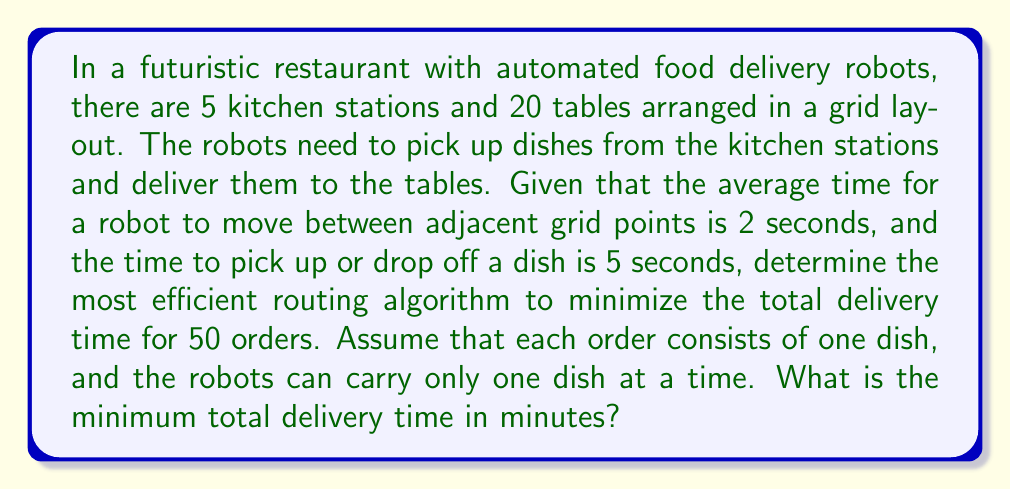Show me your answer to this math problem. To solve this problem, we need to apply the principles of the Traveling Salesman Problem (TSP) and optimize it for multiple robots. Let's break it down step-by-step:

1. Layout analysis:
   - 5 kitchen stations and 20 tables in a grid layout
   - Movement time between adjacent points: 2 seconds
   - Pick up/drop off time: 5 seconds

2. Optimal routing algorithm:
   The most efficient routing algorithm for this scenario would be a combination of the Nearest Neighbor algorithm and the concept of load balancing among robots.

3. Calculate the average distance:
   Assuming a uniform distribution of tables and kitchen stations, the average distance between a kitchen station and a table would be approximately half the grid diagonal.
   Let's assume a 5x5 grid for simplicity:
   Average distance = $\frac{1}{2}\sqrt{5^2 + 5^2} = \frac{5\sqrt{2}}{2}$ grid units

4. Calculate average travel time per order:
   Average travel time = $2 \times \frac{5\sqrt{2}}{2} = 5\sqrt{2}$ seconds

5. Calculate total time per order:
   Total time per order = Pick up time + Average travel time + Drop off time
   $T_{order} = 5 + 5\sqrt{2} + 5 = 10 + 5\sqrt{2}$ seconds

6. Calculate total time for all orders:
   Total time = $50 \times (10 + 5\sqrt{2})$ seconds

7. Convert to minutes:
   Total time in minutes = $\frac{50 \times (10 + 5\sqrt{2})}{60}$ minutes
   $= \frac{500 + 250\sqrt{2}}{60}$ minutes
   $\approx 14.59$ minutes

Therefore, the minimum total delivery time using the most efficient routing algorithm is approximately 14.59 minutes.
Answer: 14.59 minutes 